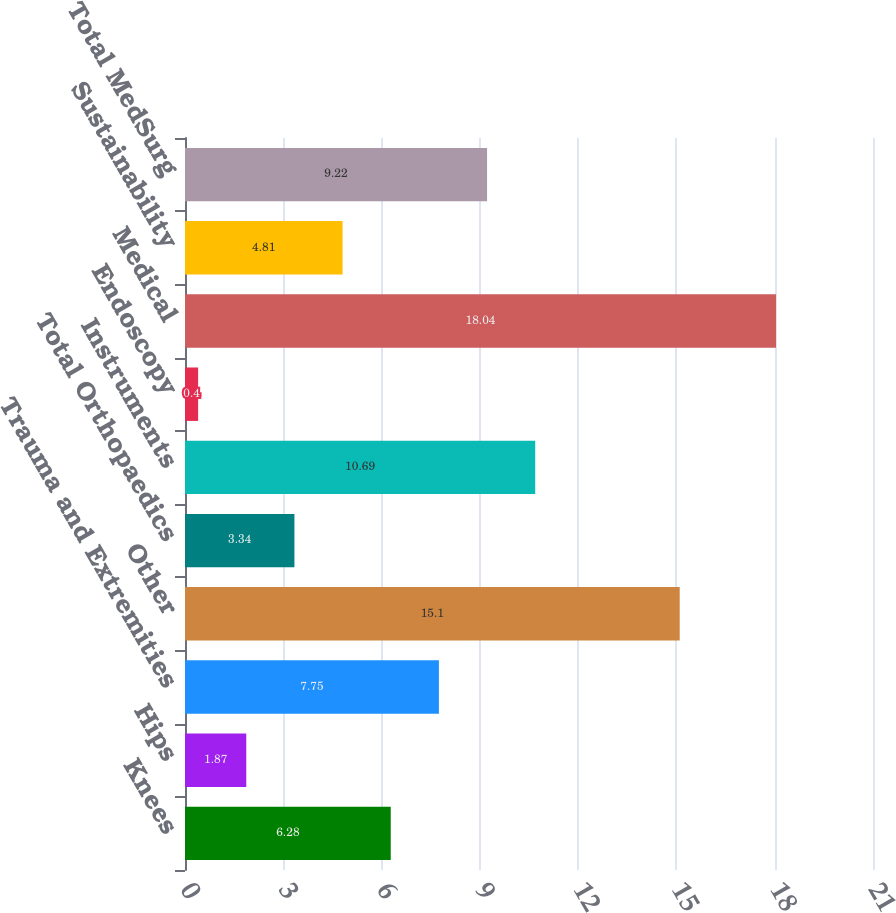<chart> <loc_0><loc_0><loc_500><loc_500><bar_chart><fcel>Knees<fcel>Hips<fcel>Trauma and Extremities<fcel>Other<fcel>Total Orthopaedics<fcel>Instruments<fcel>Endoscopy<fcel>Medical<fcel>Sustainability<fcel>Total MedSurg<nl><fcel>6.28<fcel>1.87<fcel>7.75<fcel>15.1<fcel>3.34<fcel>10.69<fcel>0.4<fcel>18.04<fcel>4.81<fcel>9.22<nl></chart> 